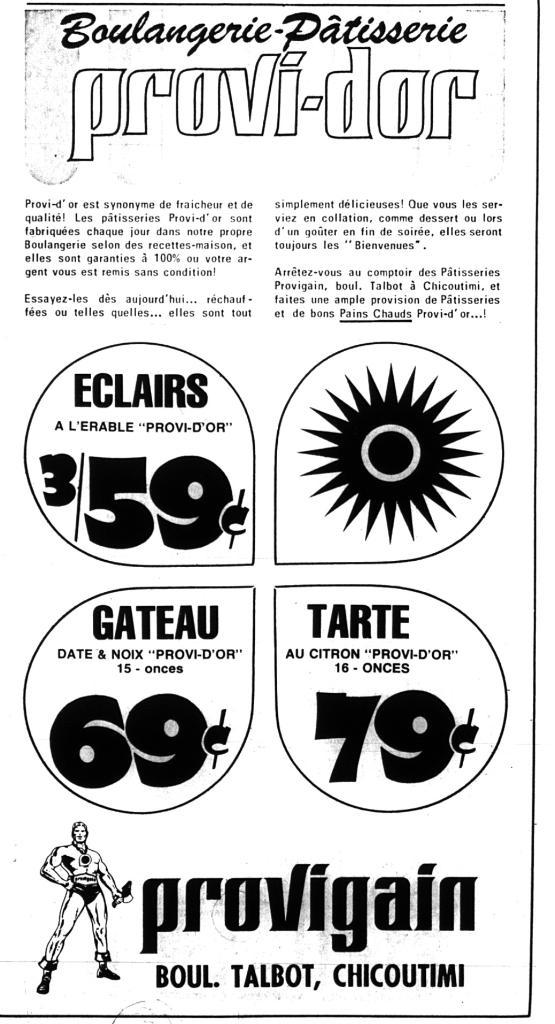What is present in the image that features a visual representation? There is a poster in the image. What is depicted in the picture on the poster? The poster contains a picture of a person. What can be found on the poster in addition to the image? There is text written on the poster. What type of chicken can be seen blowing a scent towards the person in the image? There is no chicken or scent present in the image; it only features a poster with a picture of a person and text. 